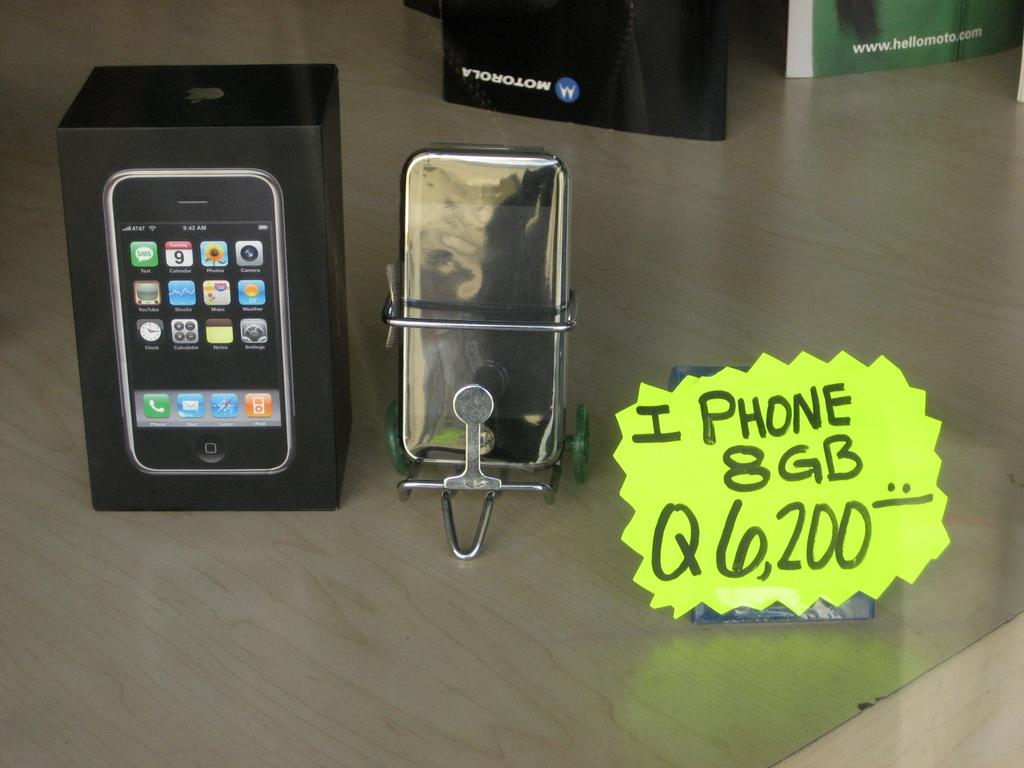<image>
Present a compact description of the photo's key features. A bright yellow sign is next to a mobile device, advertising the IPhone, 8GB. 